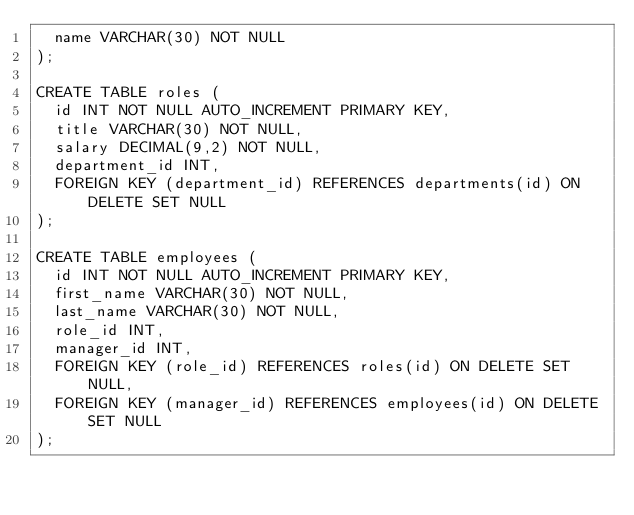<code> <loc_0><loc_0><loc_500><loc_500><_SQL_>  name VARCHAR(30) NOT NULL
);

CREATE TABLE roles (
  id INT NOT NULL AUTO_INCREMENT PRIMARY KEY,
  title VARCHAR(30) NOT NULL,
  salary DECIMAL(9,2) NOT NULL,
  department_id INT,
  FOREIGN KEY (department_id) REFERENCES departments(id) ON DELETE SET NULL
);

CREATE TABLE employees (
  id INT NOT NULL AUTO_INCREMENT PRIMARY KEY,
  first_name VARCHAR(30) NOT NULL,
  last_name VARCHAR(30) NOT NULL,
  role_id INT,
  manager_id INT,
  FOREIGN KEY (role_id) REFERENCES roles(id) ON DELETE SET NULL,
  FOREIGN KEY (manager_id) REFERENCES employees(id) ON DELETE SET NULL
);</code> 